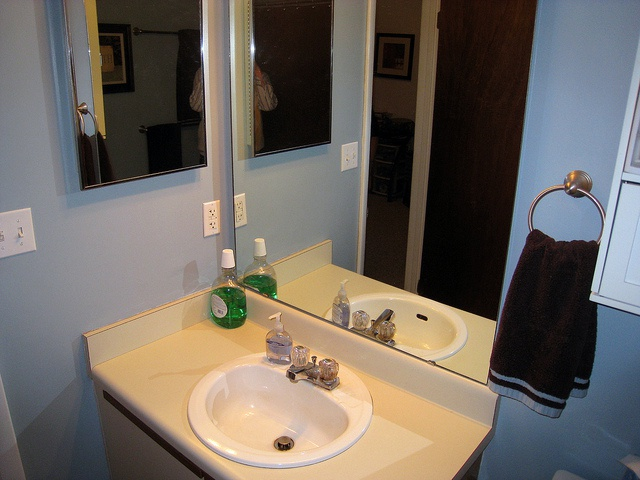Describe the objects in this image and their specific colors. I can see sink in gray, tan, lightgray, and darkgray tones, bottle in gray, darkgreen, and darkgray tones, people in gray, black, and maroon tones, and bottle in gray, tan, and darkgray tones in this image. 